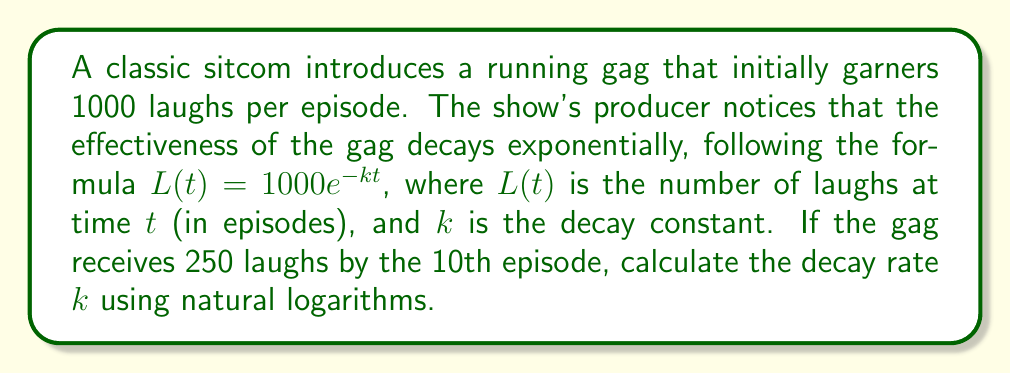Can you solve this math problem? 1) We start with the given formula: $L(t) = 1000e^{-kt}$

2) We know that at $t = 10$ episodes, $L(10) = 250$ laughs. Let's substitute these values:

   $250 = 1000e^{-k(10)}$

3) Divide both sides by 1000:

   $\frac{250}{1000} = e^{-10k}$

4) Simplify:

   $0.25 = e^{-10k}$

5) Take the natural logarithm of both sides:

   $\ln(0.25) = \ln(e^{-10k})$

6) Simplify the right side using the properties of logarithms:

   $\ln(0.25) = -10k$

7) Solve for $k$:

   $k = -\frac{\ln(0.25)}{10}$

8) Calculate:

   $k = -\frac{-1.3862943611}{10} = 0.1386294361$

Therefore, the decay rate $k$ is approximately 0.1386 per episode.
Answer: $k \approx 0.1386$ 